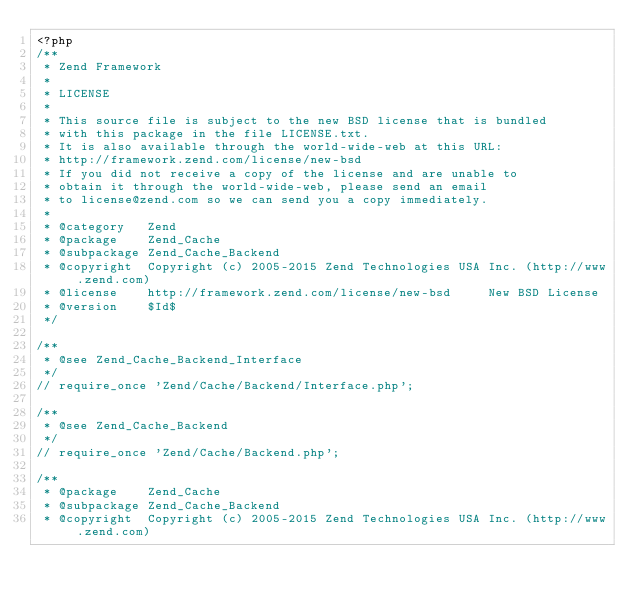Convert code to text. <code><loc_0><loc_0><loc_500><loc_500><_PHP_><?php
/**
 * Zend Framework
 *
 * LICENSE
 *
 * This source file is subject to the new BSD license that is bundled
 * with this package in the file LICENSE.txt.
 * It is also available through the world-wide-web at this URL:
 * http://framework.zend.com/license/new-bsd
 * If you did not receive a copy of the license and are unable to
 * obtain it through the world-wide-web, please send an email
 * to license@zend.com so we can send you a copy immediately.
 *
 * @category   Zend
 * @package    Zend_Cache
 * @subpackage Zend_Cache_Backend
 * @copyright  Copyright (c) 2005-2015 Zend Technologies USA Inc. (http://www.zend.com)
 * @license    http://framework.zend.com/license/new-bsd     New BSD License
 * @version    $Id$
 */

/**
 * @see Zend_Cache_Backend_Interface
 */
// require_once 'Zend/Cache/Backend/Interface.php';

/**
 * @see Zend_Cache_Backend
 */
// require_once 'Zend/Cache/Backend.php';

/**
 * @package    Zend_Cache
 * @subpackage Zend_Cache_Backend
 * @copyright  Copyright (c) 2005-2015 Zend Technologies USA Inc. (http://www.zend.com)</code> 